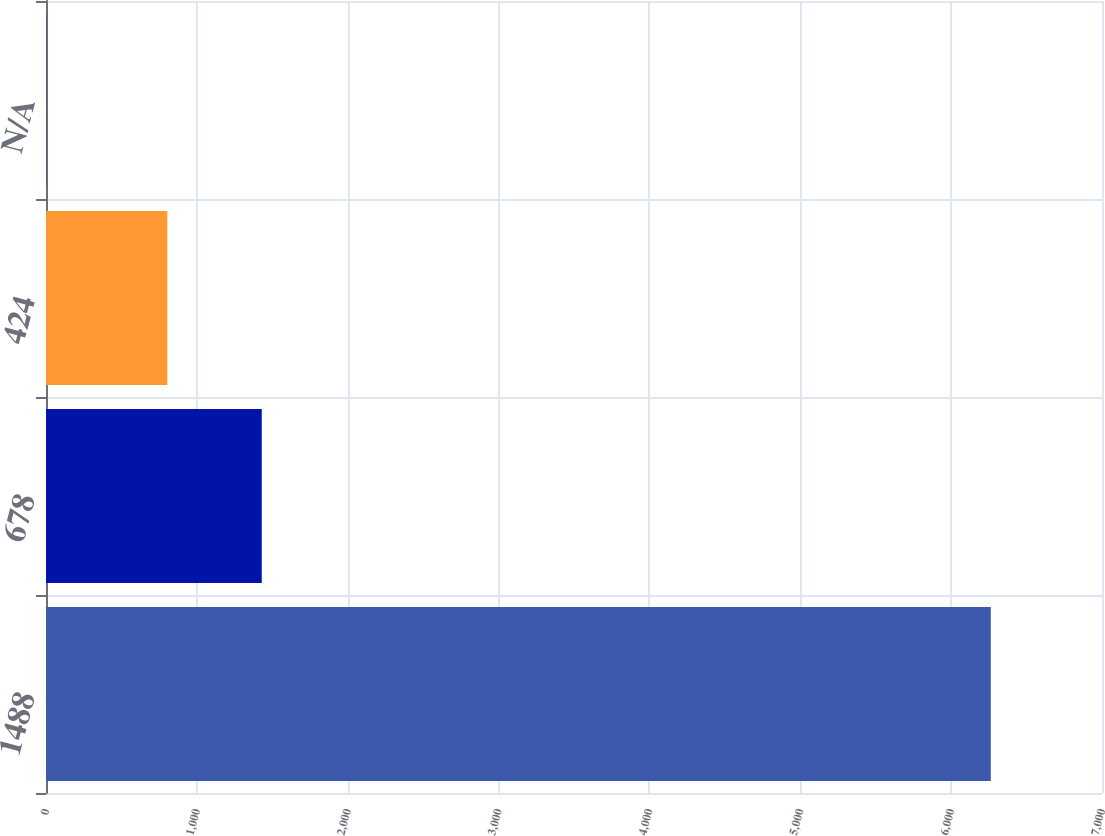<chart> <loc_0><loc_0><loc_500><loc_500><bar_chart><fcel>1488<fcel>678<fcel>424<fcel>N/A<nl><fcel>6263<fcel>1430.2<fcel>804<fcel>0.96<nl></chart> 